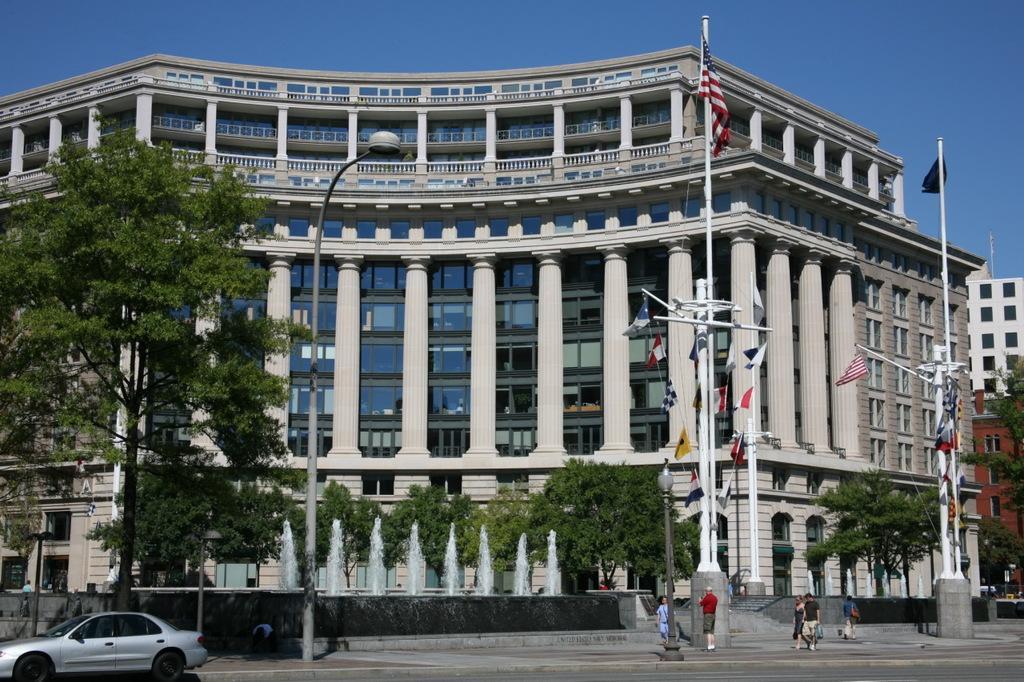Could you give a brief overview of what you see in this image? In this picture there is a huge building in the center of the image, on which there are many glass window and there are poles and trees on the right and left side of the image, there are people at the bottom side of the image and there is a car in the bottom left side of the image. 